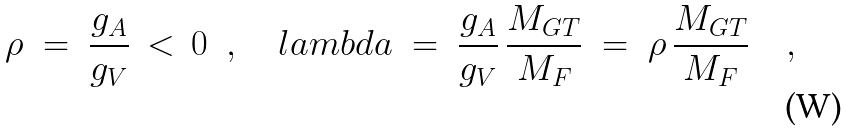Convert formula to latex. <formula><loc_0><loc_0><loc_500><loc_500>\rho \ = \ \frac { g _ { A } } { g _ { V } } \, < \, 0 \ \ , \quad l a m b d a \ = \ \frac { g _ { A } } { g _ { V } } \, \frac { M _ { G T } } { M _ { F } } \ = \ \rho \, \frac { M _ { G T } } { M _ { F } } \quad ,</formula> 